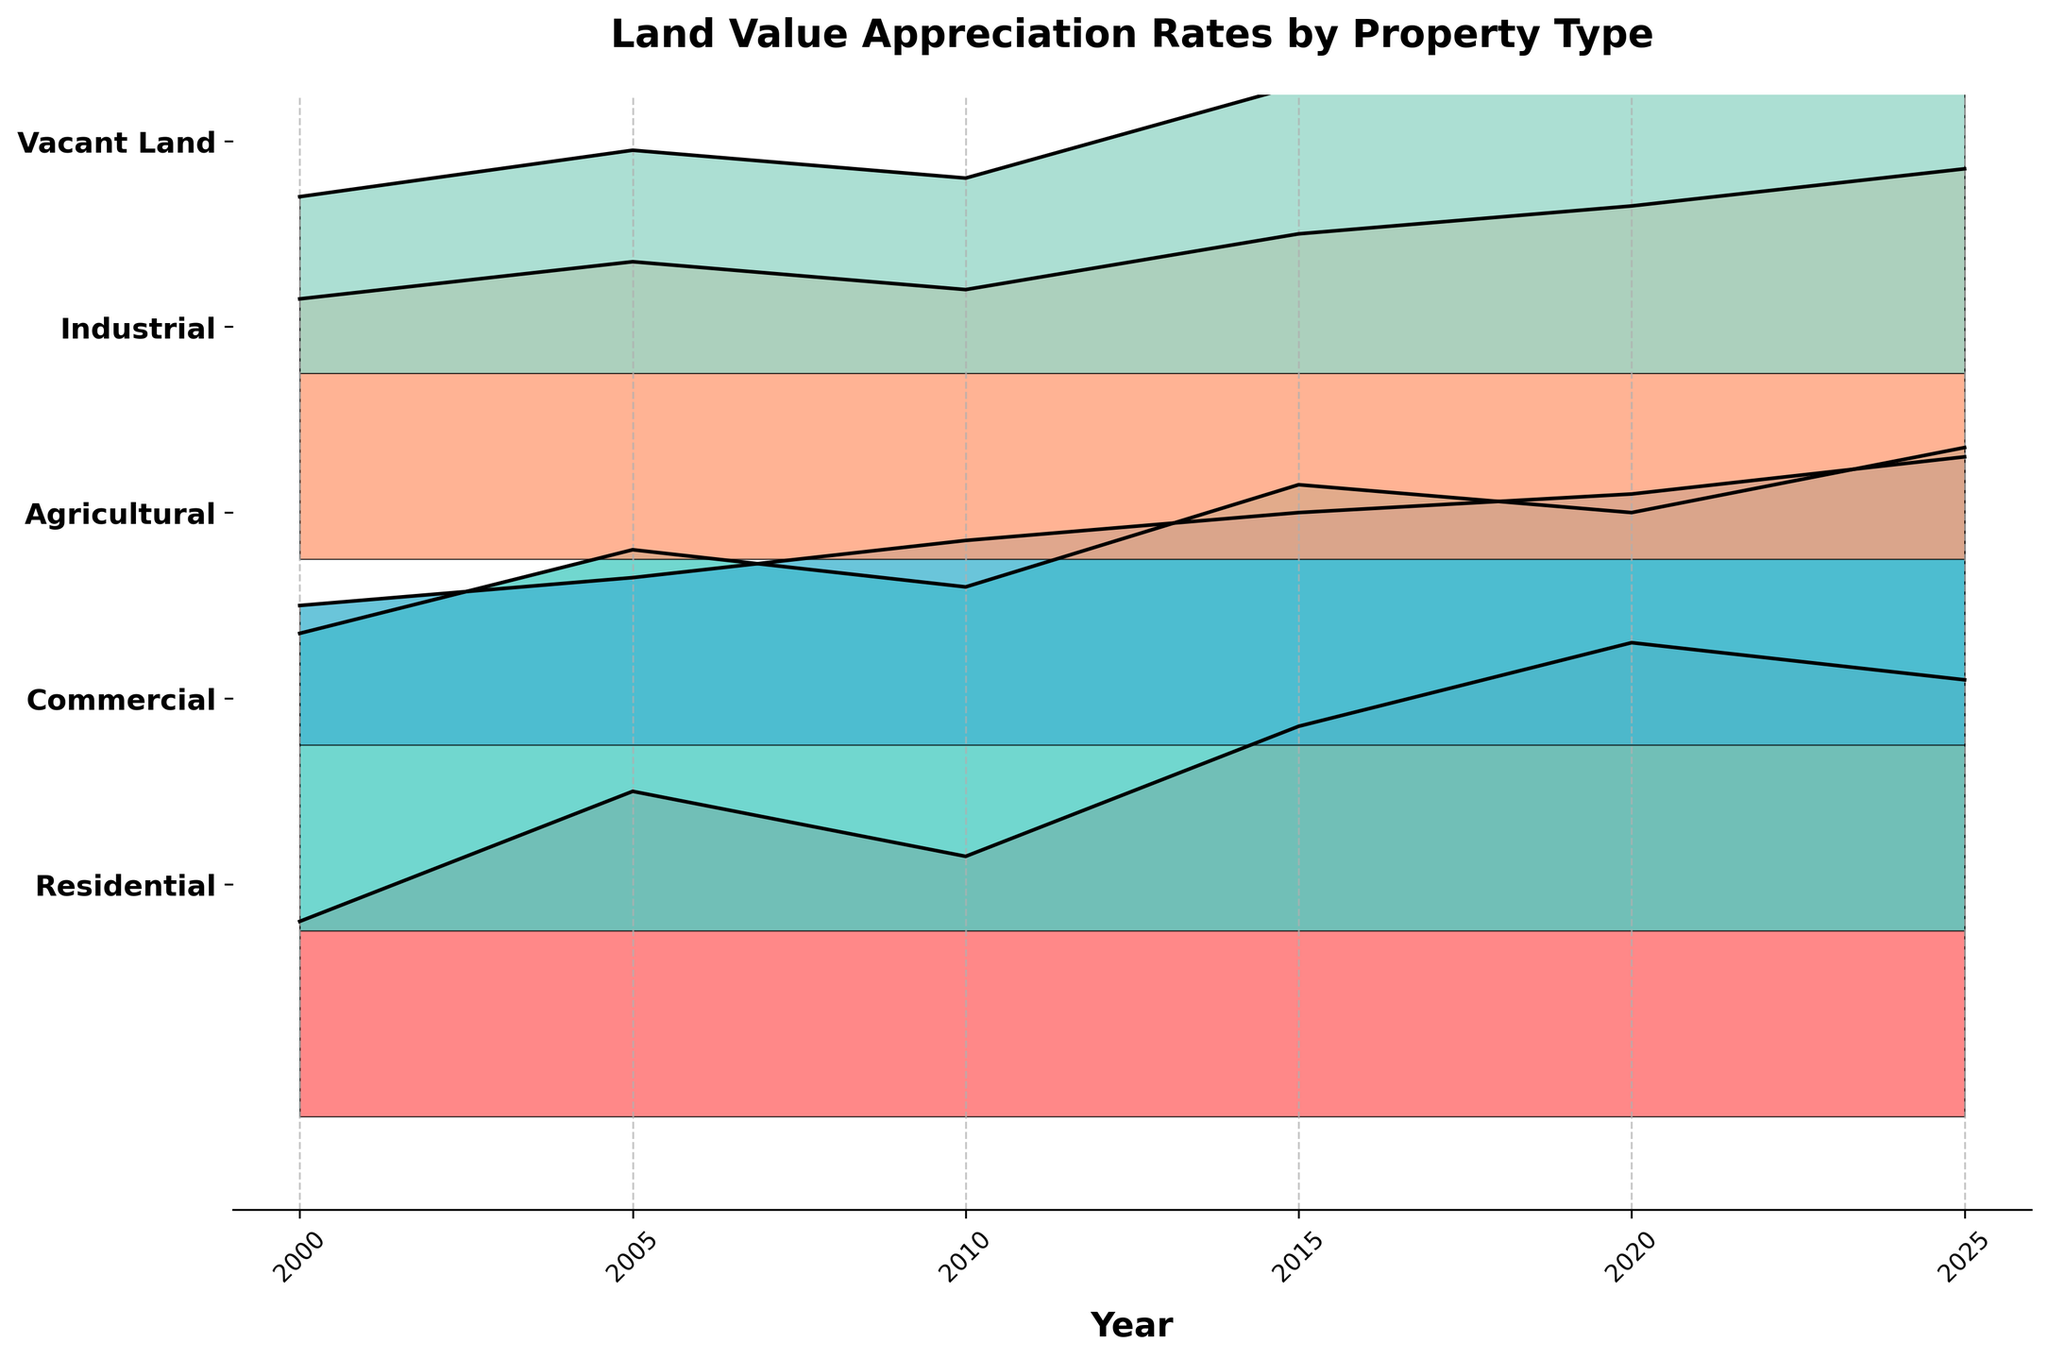What's the title of the figure? The title is displayed at the top of the figure. It reads "Land Value Appreciation Rates by Property Type".
Answer: Land Value Appreciation Rates by Property Type How many property types are compared in the figure? The property types are listed on the y-axis. There are five y-tick labels, indicating five different property types.
Answer: Five Which property type has the highest appreciation rate in 2020? Look along the x-axis at the year 2020 and examine the ridgeline plots for each property type. The highest peak in 2020 is for "Residential" property.
Answer: Residential Between which years did the "Commercial" property type see a decrease in appreciation rates? Examine the "Commercial" property plot and observe the change in heights between consecutive years. From 2015 to 2020, the line for "Commercial" property dips, indicating a decrease.
Answer: 2015 to 2020 What is the average appreciation rate of "Agricultural" land from 2000 to 2025? Sum the appreciation rates of "Agricultural" land for the years 2000, 2005, 2010, 2015, 2020, and 2025: (1.5 + 1.8 + 2.2 + 2.5 + 2.7 + 3.1) = 13.8, and then divide by the number of years (6).
Answer: 2.3 Which property type showed the most consistent appreciation rate trend over the years? Examine the trend lines for each property type. "Industrial" property has a relatively smooth and upward trend without significant fluctuations.
Answer: Industrial What is the biggest increase in appreciation rate for "Vacant Land" between two consecutive years? Check the ridgeline plot for "Vacant Land" and the differences between consecutive years: (2005-2000) = 0.5, (2010-2005) = -0.3, (2015-2010) = 1.0, (2020-2015) = 0.5, (2025-2020) = 0.4. The biggest increase is between 2010 and 2015.
Answer: 1.0 Which year saw the highest overall appreciation rates across all property types? Look at where the peaks are highest for all property types in the given years. The year 2020 has generally high peaks, but the highest across all types seems to be in 2025.
Answer: 2025 How does the appreciation rate of "Commercial" property in 2015 compare to that of "Residential" property in 2000? Compare the peaks for "Commercial" in 2015 and "Residential" in 2000. "Commercial" in 2015 is significantly higher at 4.8 compared to "Residential" in 2000 at 2.1.
Answer: Higher 